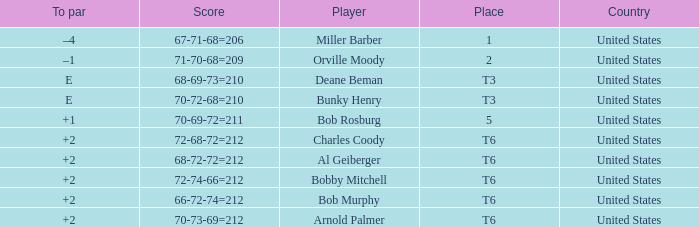What is the score of player bob rosburg? 70-69-72=211. Could you help me parse every detail presented in this table? {'header': ['To par', 'Score', 'Player', 'Place', 'Country'], 'rows': [['–4', '67-71-68=206', 'Miller Barber', '1', 'United States'], ['–1', '71-70-68=209', 'Orville Moody', '2', 'United States'], ['E', '68-69-73=210', 'Deane Beman', 'T3', 'United States'], ['E', '70-72-68=210', 'Bunky Henry', 'T3', 'United States'], ['+1', '70-69-72=211', 'Bob Rosburg', '5', 'United States'], ['+2', '72-68-72=212', 'Charles Coody', 'T6', 'United States'], ['+2', '68-72-72=212', 'Al Geiberger', 'T6', 'United States'], ['+2', '72-74-66=212', 'Bobby Mitchell', 'T6', 'United States'], ['+2', '66-72-74=212', 'Bob Murphy', 'T6', 'United States'], ['+2', '70-73-69=212', 'Arnold Palmer', 'T6', 'United States']]} 